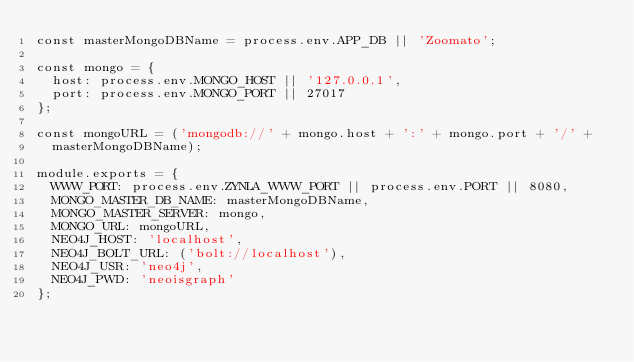<code> <loc_0><loc_0><loc_500><loc_500><_JavaScript_>const masterMongoDBName = process.env.APP_DB || 'Zoomato';

const mongo = {
  host: process.env.MONGO_HOST || '127.0.0.1',
  port: process.env.MONGO_PORT || 27017
};

const mongoURL = ('mongodb://' + mongo.host + ':' + mongo.port + '/' +
  masterMongoDBName);

module.exports = {
  WWW_PORT: process.env.ZYNLA_WWW_PORT || process.env.PORT || 8080,
  MONGO_MASTER_DB_NAME: masterMongoDBName,
  MONGO_MASTER_SERVER: mongo,
  MONGO_URL: mongoURL,
  NEO4J_HOST: 'localhost',
  NEO4J_BOLT_URL: ('bolt://localhost'),
  NEO4J_USR: 'neo4j',
  NEO4J_PWD: 'neoisgraph'
};
</code> 